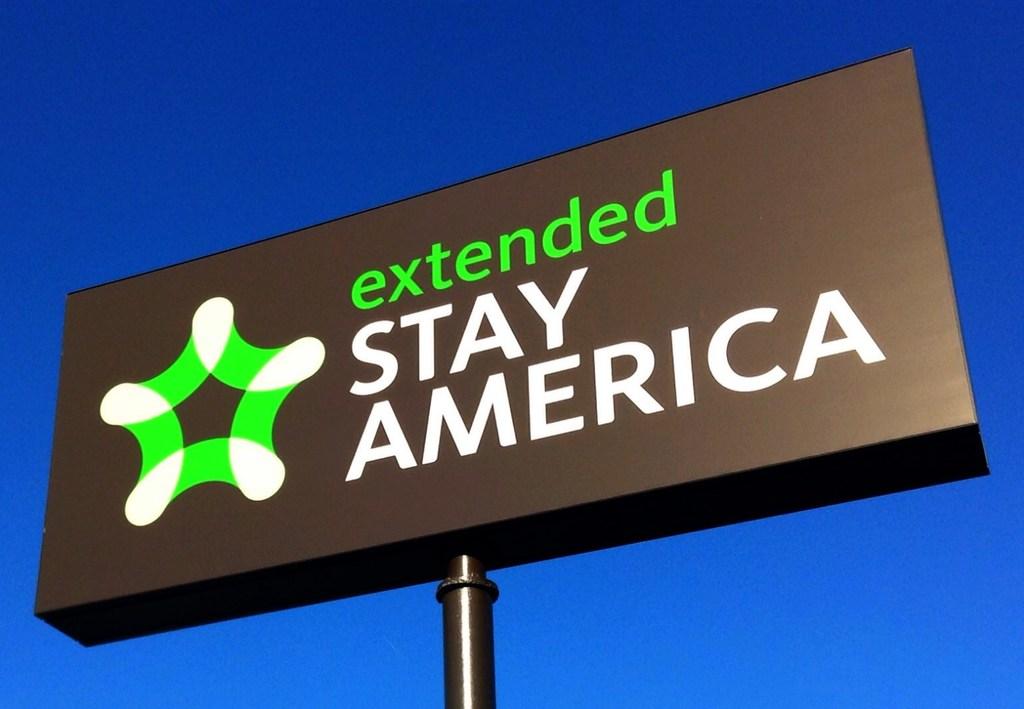What type of hotel stay is being advertised?
Your answer should be very brief. Extended. What type of stay is stay america?
Offer a very short reply. Extended. 